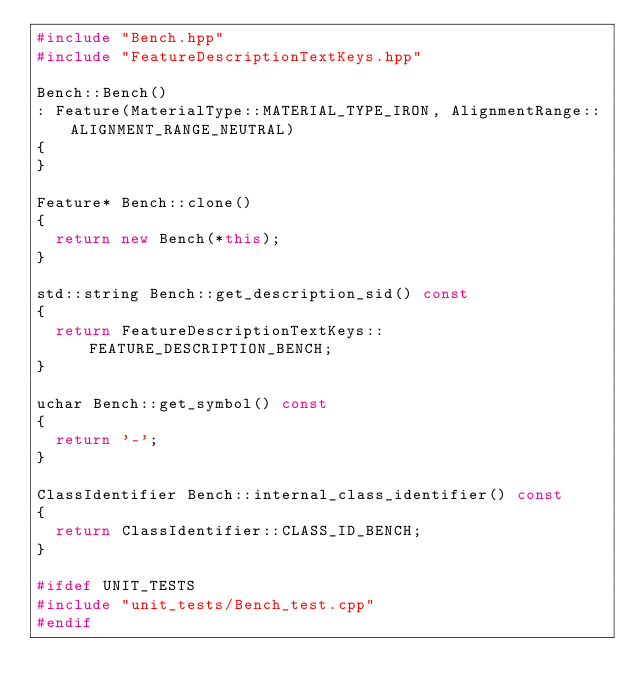<code> <loc_0><loc_0><loc_500><loc_500><_C++_>#include "Bench.hpp"
#include "FeatureDescriptionTextKeys.hpp"

Bench::Bench()
: Feature(MaterialType::MATERIAL_TYPE_IRON, AlignmentRange::ALIGNMENT_RANGE_NEUTRAL)
{
}

Feature* Bench::clone()
{
  return new Bench(*this);
}

std::string Bench::get_description_sid() const
{
  return FeatureDescriptionTextKeys::FEATURE_DESCRIPTION_BENCH;
}

uchar Bench::get_symbol() const
{
  return '-';
}

ClassIdentifier Bench::internal_class_identifier() const
{
  return ClassIdentifier::CLASS_ID_BENCH;
}

#ifdef UNIT_TESTS
#include "unit_tests/Bench_test.cpp"
#endif

</code> 